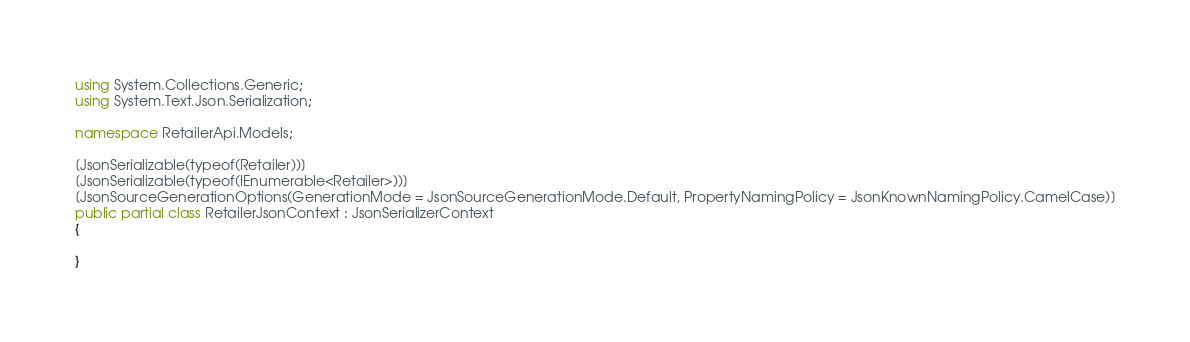<code> <loc_0><loc_0><loc_500><loc_500><_C#_>using System.Collections.Generic;
using System.Text.Json.Serialization;

namespace RetailerApi.Models;

[JsonSerializable(typeof(Retailer))]
[JsonSerializable(typeof(IEnumerable<Retailer>))]
[JsonSourceGenerationOptions(GenerationMode = JsonSourceGenerationMode.Default, PropertyNamingPolicy = JsonKnownNamingPolicy.CamelCase)]
public partial class RetailerJsonContext : JsonSerializerContext
{

}
</code> 